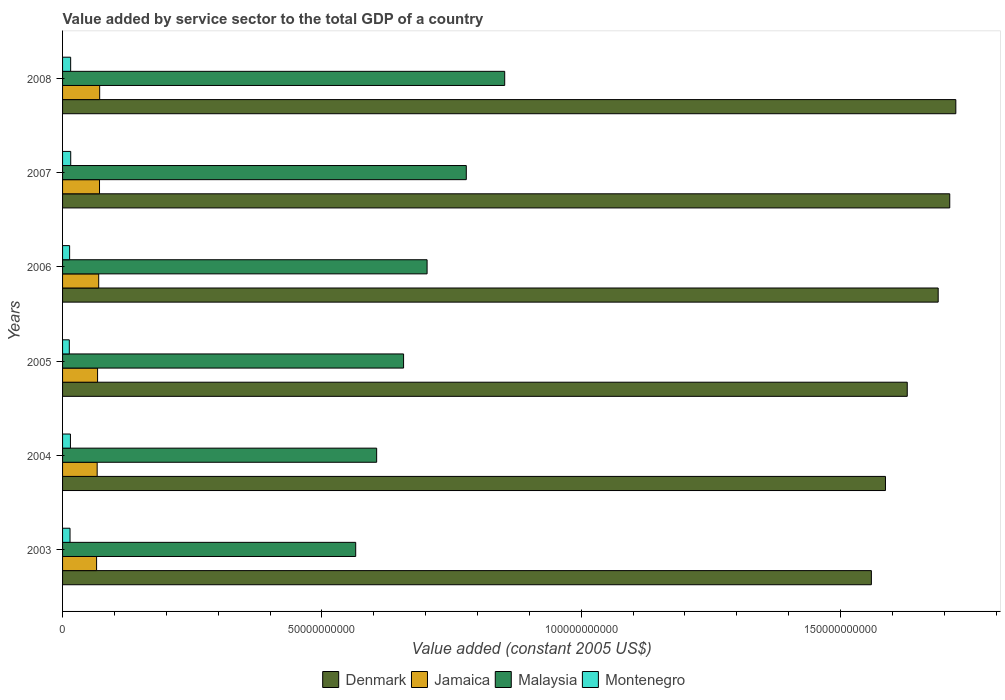How many groups of bars are there?
Your answer should be very brief. 6. Are the number of bars per tick equal to the number of legend labels?
Provide a short and direct response. Yes. How many bars are there on the 4th tick from the bottom?
Make the answer very short. 4. What is the label of the 1st group of bars from the top?
Make the answer very short. 2008. In how many cases, is the number of bars for a given year not equal to the number of legend labels?
Give a very brief answer. 0. What is the value added by service sector in Malaysia in 2008?
Give a very brief answer. 8.53e+1. Across all years, what is the maximum value added by service sector in Montenegro?
Offer a very short reply. 1.57e+09. Across all years, what is the minimum value added by service sector in Malaysia?
Provide a succinct answer. 5.65e+1. In which year was the value added by service sector in Malaysia minimum?
Offer a terse response. 2003. What is the total value added by service sector in Malaysia in the graph?
Your answer should be very brief. 4.16e+11. What is the difference between the value added by service sector in Jamaica in 2003 and that in 2007?
Offer a very short reply. -5.63e+08. What is the difference between the value added by service sector in Malaysia in 2006 and the value added by service sector in Denmark in 2007?
Offer a very short reply. -1.01e+11. What is the average value added by service sector in Malaysia per year?
Keep it short and to the point. 6.94e+1. In the year 2008, what is the difference between the value added by service sector in Jamaica and value added by service sector in Malaysia?
Ensure brevity in your answer.  -7.81e+1. What is the ratio of the value added by service sector in Denmark in 2004 to that in 2005?
Offer a very short reply. 0.97. Is the value added by service sector in Jamaica in 2006 less than that in 2008?
Provide a short and direct response. Yes. Is the difference between the value added by service sector in Jamaica in 2006 and 2007 greater than the difference between the value added by service sector in Malaysia in 2006 and 2007?
Offer a terse response. Yes. What is the difference between the highest and the second highest value added by service sector in Jamaica?
Your answer should be very brief. 2.92e+07. What is the difference between the highest and the lowest value added by service sector in Denmark?
Offer a very short reply. 1.63e+1. Is it the case that in every year, the sum of the value added by service sector in Montenegro and value added by service sector in Jamaica is greater than the sum of value added by service sector in Denmark and value added by service sector in Malaysia?
Your answer should be compact. No. What does the 3rd bar from the top in 2004 represents?
Provide a succinct answer. Jamaica. What does the 3rd bar from the bottom in 2008 represents?
Your answer should be compact. Malaysia. Is it the case that in every year, the sum of the value added by service sector in Montenegro and value added by service sector in Denmark is greater than the value added by service sector in Jamaica?
Provide a short and direct response. Yes. How many bars are there?
Provide a succinct answer. 24. Are all the bars in the graph horizontal?
Your answer should be compact. Yes. How many years are there in the graph?
Give a very brief answer. 6. Are the values on the major ticks of X-axis written in scientific E-notation?
Give a very brief answer. No. Where does the legend appear in the graph?
Ensure brevity in your answer.  Bottom center. How many legend labels are there?
Your answer should be compact. 4. What is the title of the graph?
Your response must be concise. Value added by service sector to the total GDP of a country. Does "Middle East & North Africa (developing only)" appear as one of the legend labels in the graph?
Offer a terse response. No. What is the label or title of the X-axis?
Give a very brief answer. Value added (constant 2005 US$). What is the label or title of the Y-axis?
Your answer should be compact. Years. What is the Value added (constant 2005 US$) of Denmark in 2003?
Offer a terse response. 1.56e+11. What is the Value added (constant 2005 US$) in Jamaica in 2003?
Offer a very short reply. 6.56e+09. What is the Value added (constant 2005 US$) of Malaysia in 2003?
Provide a short and direct response. 5.65e+1. What is the Value added (constant 2005 US$) of Montenegro in 2003?
Ensure brevity in your answer.  1.44e+09. What is the Value added (constant 2005 US$) in Denmark in 2004?
Make the answer very short. 1.59e+11. What is the Value added (constant 2005 US$) in Jamaica in 2004?
Your answer should be very brief. 6.67e+09. What is the Value added (constant 2005 US$) in Malaysia in 2004?
Your answer should be compact. 6.06e+1. What is the Value added (constant 2005 US$) in Montenegro in 2004?
Give a very brief answer. 1.52e+09. What is the Value added (constant 2005 US$) of Denmark in 2005?
Give a very brief answer. 1.63e+11. What is the Value added (constant 2005 US$) in Jamaica in 2005?
Your answer should be compact. 6.75e+09. What is the Value added (constant 2005 US$) of Malaysia in 2005?
Give a very brief answer. 6.58e+1. What is the Value added (constant 2005 US$) in Montenegro in 2005?
Your answer should be very brief. 1.30e+09. What is the Value added (constant 2005 US$) in Denmark in 2006?
Your answer should be compact. 1.69e+11. What is the Value added (constant 2005 US$) of Jamaica in 2006?
Provide a succinct answer. 6.97e+09. What is the Value added (constant 2005 US$) in Malaysia in 2006?
Offer a terse response. 7.03e+1. What is the Value added (constant 2005 US$) in Montenegro in 2006?
Provide a succinct answer. 1.36e+09. What is the Value added (constant 2005 US$) in Denmark in 2007?
Make the answer very short. 1.71e+11. What is the Value added (constant 2005 US$) of Jamaica in 2007?
Make the answer very short. 7.12e+09. What is the Value added (constant 2005 US$) of Malaysia in 2007?
Provide a short and direct response. 7.78e+1. What is the Value added (constant 2005 US$) in Montenegro in 2007?
Give a very brief answer. 1.57e+09. What is the Value added (constant 2005 US$) in Denmark in 2008?
Make the answer very short. 1.72e+11. What is the Value added (constant 2005 US$) of Jamaica in 2008?
Make the answer very short. 7.15e+09. What is the Value added (constant 2005 US$) of Malaysia in 2008?
Keep it short and to the point. 8.53e+1. What is the Value added (constant 2005 US$) of Montenegro in 2008?
Keep it short and to the point. 1.56e+09. Across all years, what is the maximum Value added (constant 2005 US$) of Denmark?
Make the answer very short. 1.72e+11. Across all years, what is the maximum Value added (constant 2005 US$) of Jamaica?
Offer a terse response. 7.15e+09. Across all years, what is the maximum Value added (constant 2005 US$) in Malaysia?
Keep it short and to the point. 8.53e+1. Across all years, what is the maximum Value added (constant 2005 US$) of Montenegro?
Offer a very short reply. 1.57e+09. Across all years, what is the minimum Value added (constant 2005 US$) in Denmark?
Ensure brevity in your answer.  1.56e+11. Across all years, what is the minimum Value added (constant 2005 US$) of Jamaica?
Give a very brief answer. 6.56e+09. Across all years, what is the minimum Value added (constant 2005 US$) in Malaysia?
Offer a very short reply. 5.65e+1. Across all years, what is the minimum Value added (constant 2005 US$) of Montenegro?
Your response must be concise. 1.30e+09. What is the total Value added (constant 2005 US$) of Denmark in the graph?
Ensure brevity in your answer.  9.90e+11. What is the total Value added (constant 2005 US$) in Jamaica in the graph?
Provide a short and direct response. 4.12e+1. What is the total Value added (constant 2005 US$) of Malaysia in the graph?
Offer a very short reply. 4.16e+11. What is the total Value added (constant 2005 US$) in Montenegro in the graph?
Offer a very short reply. 8.75e+09. What is the difference between the Value added (constant 2005 US$) of Denmark in 2003 and that in 2004?
Offer a very short reply. -2.72e+09. What is the difference between the Value added (constant 2005 US$) in Jamaica in 2003 and that in 2004?
Ensure brevity in your answer.  -1.10e+08. What is the difference between the Value added (constant 2005 US$) of Malaysia in 2003 and that in 2004?
Make the answer very short. -4.04e+09. What is the difference between the Value added (constant 2005 US$) of Montenegro in 2003 and that in 2004?
Offer a very short reply. -7.69e+07. What is the difference between the Value added (constant 2005 US$) of Denmark in 2003 and that in 2005?
Give a very brief answer. -6.92e+09. What is the difference between the Value added (constant 2005 US$) in Jamaica in 2003 and that in 2005?
Offer a very short reply. -1.91e+08. What is the difference between the Value added (constant 2005 US$) of Malaysia in 2003 and that in 2005?
Your answer should be very brief. -9.23e+09. What is the difference between the Value added (constant 2005 US$) of Montenegro in 2003 and that in 2005?
Offer a terse response. 1.39e+08. What is the difference between the Value added (constant 2005 US$) in Denmark in 2003 and that in 2006?
Offer a terse response. -1.29e+1. What is the difference between the Value added (constant 2005 US$) in Jamaica in 2003 and that in 2006?
Make the answer very short. -4.08e+08. What is the difference between the Value added (constant 2005 US$) of Malaysia in 2003 and that in 2006?
Provide a succinct answer. -1.38e+1. What is the difference between the Value added (constant 2005 US$) of Montenegro in 2003 and that in 2006?
Provide a succinct answer. 7.83e+07. What is the difference between the Value added (constant 2005 US$) in Denmark in 2003 and that in 2007?
Offer a terse response. -1.51e+1. What is the difference between the Value added (constant 2005 US$) of Jamaica in 2003 and that in 2007?
Your response must be concise. -5.63e+08. What is the difference between the Value added (constant 2005 US$) of Malaysia in 2003 and that in 2007?
Keep it short and to the point. -2.13e+1. What is the difference between the Value added (constant 2005 US$) of Montenegro in 2003 and that in 2007?
Provide a short and direct response. -1.31e+08. What is the difference between the Value added (constant 2005 US$) of Denmark in 2003 and that in 2008?
Provide a succinct answer. -1.63e+1. What is the difference between the Value added (constant 2005 US$) in Jamaica in 2003 and that in 2008?
Ensure brevity in your answer.  -5.92e+08. What is the difference between the Value added (constant 2005 US$) in Malaysia in 2003 and that in 2008?
Your answer should be compact. -2.87e+1. What is the difference between the Value added (constant 2005 US$) of Montenegro in 2003 and that in 2008?
Keep it short and to the point. -1.21e+08. What is the difference between the Value added (constant 2005 US$) in Denmark in 2004 and that in 2005?
Give a very brief answer. -4.20e+09. What is the difference between the Value added (constant 2005 US$) in Jamaica in 2004 and that in 2005?
Keep it short and to the point. -8.05e+07. What is the difference between the Value added (constant 2005 US$) in Malaysia in 2004 and that in 2005?
Ensure brevity in your answer.  -5.19e+09. What is the difference between the Value added (constant 2005 US$) in Montenegro in 2004 and that in 2005?
Your response must be concise. 2.16e+08. What is the difference between the Value added (constant 2005 US$) in Denmark in 2004 and that in 2006?
Offer a terse response. -1.02e+1. What is the difference between the Value added (constant 2005 US$) of Jamaica in 2004 and that in 2006?
Your response must be concise. -2.97e+08. What is the difference between the Value added (constant 2005 US$) of Malaysia in 2004 and that in 2006?
Provide a short and direct response. -9.72e+09. What is the difference between the Value added (constant 2005 US$) in Montenegro in 2004 and that in 2006?
Provide a succinct answer. 1.55e+08. What is the difference between the Value added (constant 2005 US$) of Denmark in 2004 and that in 2007?
Provide a succinct answer. -1.24e+1. What is the difference between the Value added (constant 2005 US$) in Jamaica in 2004 and that in 2007?
Offer a terse response. -4.53e+08. What is the difference between the Value added (constant 2005 US$) in Malaysia in 2004 and that in 2007?
Keep it short and to the point. -1.73e+1. What is the difference between the Value added (constant 2005 US$) of Montenegro in 2004 and that in 2007?
Keep it short and to the point. -5.41e+07. What is the difference between the Value added (constant 2005 US$) in Denmark in 2004 and that in 2008?
Your answer should be compact. -1.36e+1. What is the difference between the Value added (constant 2005 US$) in Jamaica in 2004 and that in 2008?
Ensure brevity in your answer.  -4.82e+08. What is the difference between the Value added (constant 2005 US$) of Malaysia in 2004 and that in 2008?
Give a very brief answer. -2.47e+1. What is the difference between the Value added (constant 2005 US$) of Montenegro in 2004 and that in 2008?
Provide a succinct answer. -4.37e+07. What is the difference between the Value added (constant 2005 US$) of Denmark in 2005 and that in 2006?
Offer a terse response. -5.96e+09. What is the difference between the Value added (constant 2005 US$) of Jamaica in 2005 and that in 2006?
Your answer should be very brief. -2.17e+08. What is the difference between the Value added (constant 2005 US$) in Malaysia in 2005 and that in 2006?
Make the answer very short. -4.53e+09. What is the difference between the Value added (constant 2005 US$) in Montenegro in 2005 and that in 2006?
Ensure brevity in your answer.  -6.05e+07. What is the difference between the Value added (constant 2005 US$) of Denmark in 2005 and that in 2007?
Provide a succinct answer. -8.19e+09. What is the difference between the Value added (constant 2005 US$) in Jamaica in 2005 and that in 2007?
Offer a terse response. -3.72e+08. What is the difference between the Value added (constant 2005 US$) of Malaysia in 2005 and that in 2007?
Offer a very short reply. -1.21e+1. What is the difference between the Value added (constant 2005 US$) in Montenegro in 2005 and that in 2007?
Keep it short and to the point. -2.70e+08. What is the difference between the Value added (constant 2005 US$) in Denmark in 2005 and that in 2008?
Provide a succinct answer. -9.37e+09. What is the difference between the Value added (constant 2005 US$) of Jamaica in 2005 and that in 2008?
Keep it short and to the point. -4.02e+08. What is the difference between the Value added (constant 2005 US$) in Malaysia in 2005 and that in 2008?
Offer a very short reply. -1.95e+1. What is the difference between the Value added (constant 2005 US$) in Montenegro in 2005 and that in 2008?
Make the answer very short. -2.59e+08. What is the difference between the Value added (constant 2005 US$) in Denmark in 2006 and that in 2007?
Give a very brief answer. -2.23e+09. What is the difference between the Value added (constant 2005 US$) in Jamaica in 2006 and that in 2007?
Give a very brief answer. -1.55e+08. What is the difference between the Value added (constant 2005 US$) in Malaysia in 2006 and that in 2007?
Provide a succinct answer. -7.56e+09. What is the difference between the Value added (constant 2005 US$) of Montenegro in 2006 and that in 2007?
Offer a very short reply. -2.09e+08. What is the difference between the Value added (constant 2005 US$) in Denmark in 2006 and that in 2008?
Make the answer very short. -3.40e+09. What is the difference between the Value added (constant 2005 US$) in Jamaica in 2006 and that in 2008?
Your answer should be very brief. -1.85e+08. What is the difference between the Value added (constant 2005 US$) of Malaysia in 2006 and that in 2008?
Your answer should be compact. -1.50e+1. What is the difference between the Value added (constant 2005 US$) in Montenegro in 2006 and that in 2008?
Your response must be concise. -1.99e+08. What is the difference between the Value added (constant 2005 US$) of Denmark in 2007 and that in 2008?
Your response must be concise. -1.17e+09. What is the difference between the Value added (constant 2005 US$) in Jamaica in 2007 and that in 2008?
Offer a terse response. -2.92e+07. What is the difference between the Value added (constant 2005 US$) of Malaysia in 2007 and that in 2008?
Provide a succinct answer. -7.41e+09. What is the difference between the Value added (constant 2005 US$) in Montenegro in 2007 and that in 2008?
Ensure brevity in your answer.  1.04e+07. What is the difference between the Value added (constant 2005 US$) of Denmark in 2003 and the Value added (constant 2005 US$) of Jamaica in 2004?
Make the answer very short. 1.49e+11. What is the difference between the Value added (constant 2005 US$) of Denmark in 2003 and the Value added (constant 2005 US$) of Malaysia in 2004?
Make the answer very short. 9.54e+1. What is the difference between the Value added (constant 2005 US$) of Denmark in 2003 and the Value added (constant 2005 US$) of Montenegro in 2004?
Provide a short and direct response. 1.54e+11. What is the difference between the Value added (constant 2005 US$) of Jamaica in 2003 and the Value added (constant 2005 US$) of Malaysia in 2004?
Give a very brief answer. -5.40e+1. What is the difference between the Value added (constant 2005 US$) in Jamaica in 2003 and the Value added (constant 2005 US$) in Montenegro in 2004?
Offer a very short reply. 5.04e+09. What is the difference between the Value added (constant 2005 US$) of Malaysia in 2003 and the Value added (constant 2005 US$) of Montenegro in 2004?
Your answer should be very brief. 5.50e+1. What is the difference between the Value added (constant 2005 US$) of Denmark in 2003 and the Value added (constant 2005 US$) of Jamaica in 2005?
Ensure brevity in your answer.  1.49e+11. What is the difference between the Value added (constant 2005 US$) of Denmark in 2003 and the Value added (constant 2005 US$) of Malaysia in 2005?
Give a very brief answer. 9.02e+1. What is the difference between the Value added (constant 2005 US$) in Denmark in 2003 and the Value added (constant 2005 US$) in Montenegro in 2005?
Give a very brief answer. 1.55e+11. What is the difference between the Value added (constant 2005 US$) in Jamaica in 2003 and the Value added (constant 2005 US$) in Malaysia in 2005?
Offer a very short reply. -5.92e+1. What is the difference between the Value added (constant 2005 US$) of Jamaica in 2003 and the Value added (constant 2005 US$) of Montenegro in 2005?
Offer a terse response. 5.26e+09. What is the difference between the Value added (constant 2005 US$) of Malaysia in 2003 and the Value added (constant 2005 US$) of Montenegro in 2005?
Keep it short and to the point. 5.52e+1. What is the difference between the Value added (constant 2005 US$) of Denmark in 2003 and the Value added (constant 2005 US$) of Jamaica in 2006?
Your answer should be compact. 1.49e+11. What is the difference between the Value added (constant 2005 US$) of Denmark in 2003 and the Value added (constant 2005 US$) of Malaysia in 2006?
Offer a very short reply. 8.57e+1. What is the difference between the Value added (constant 2005 US$) of Denmark in 2003 and the Value added (constant 2005 US$) of Montenegro in 2006?
Offer a terse response. 1.55e+11. What is the difference between the Value added (constant 2005 US$) in Jamaica in 2003 and the Value added (constant 2005 US$) in Malaysia in 2006?
Your answer should be very brief. -6.37e+1. What is the difference between the Value added (constant 2005 US$) of Jamaica in 2003 and the Value added (constant 2005 US$) of Montenegro in 2006?
Ensure brevity in your answer.  5.20e+09. What is the difference between the Value added (constant 2005 US$) in Malaysia in 2003 and the Value added (constant 2005 US$) in Montenegro in 2006?
Your response must be concise. 5.52e+1. What is the difference between the Value added (constant 2005 US$) of Denmark in 2003 and the Value added (constant 2005 US$) of Jamaica in 2007?
Make the answer very short. 1.49e+11. What is the difference between the Value added (constant 2005 US$) in Denmark in 2003 and the Value added (constant 2005 US$) in Malaysia in 2007?
Your answer should be compact. 7.81e+1. What is the difference between the Value added (constant 2005 US$) of Denmark in 2003 and the Value added (constant 2005 US$) of Montenegro in 2007?
Make the answer very short. 1.54e+11. What is the difference between the Value added (constant 2005 US$) in Jamaica in 2003 and the Value added (constant 2005 US$) in Malaysia in 2007?
Make the answer very short. -7.13e+1. What is the difference between the Value added (constant 2005 US$) of Jamaica in 2003 and the Value added (constant 2005 US$) of Montenegro in 2007?
Your answer should be very brief. 4.99e+09. What is the difference between the Value added (constant 2005 US$) of Malaysia in 2003 and the Value added (constant 2005 US$) of Montenegro in 2007?
Ensure brevity in your answer.  5.50e+1. What is the difference between the Value added (constant 2005 US$) of Denmark in 2003 and the Value added (constant 2005 US$) of Jamaica in 2008?
Provide a succinct answer. 1.49e+11. What is the difference between the Value added (constant 2005 US$) of Denmark in 2003 and the Value added (constant 2005 US$) of Malaysia in 2008?
Offer a terse response. 7.07e+1. What is the difference between the Value added (constant 2005 US$) in Denmark in 2003 and the Value added (constant 2005 US$) in Montenegro in 2008?
Offer a terse response. 1.54e+11. What is the difference between the Value added (constant 2005 US$) in Jamaica in 2003 and the Value added (constant 2005 US$) in Malaysia in 2008?
Provide a succinct answer. -7.87e+1. What is the difference between the Value added (constant 2005 US$) of Jamaica in 2003 and the Value added (constant 2005 US$) of Montenegro in 2008?
Give a very brief answer. 5.00e+09. What is the difference between the Value added (constant 2005 US$) of Malaysia in 2003 and the Value added (constant 2005 US$) of Montenegro in 2008?
Offer a very short reply. 5.50e+1. What is the difference between the Value added (constant 2005 US$) of Denmark in 2004 and the Value added (constant 2005 US$) of Jamaica in 2005?
Make the answer very short. 1.52e+11. What is the difference between the Value added (constant 2005 US$) in Denmark in 2004 and the Value added (constant 2005 US$) in Malaysia in 2005?
Ensure brevity in your answer.  9.29e+1. What is the difference between the Value added (constant 2005 US$) in Denmark in 2004 and the Value added (constant 2005 US$) in Montenegro in 2005?
Provide a succinct answer. 1.57e+11. What is the difference between the Value added (constant 2005 US$) of Jamaica in 2004 and the Value added (constant 2005 US$) of Malaysia in 2005?
Your answer should be very brief. -5.91e+1. What is the difference between the Value added (constant 2005 US$) in Jamaica in 2004 and the Value added (constant 2005 US$) in Montenegro in 2005?
Your answer should be very brief. 5.37e+09. What is the difference between the Value added (constant 2005 US$) in Malaysia in 2004 and the Value added (constant 2005 US$) in Montenegro in 2005?
Your answer should be very brief. 5.93e+1. What is the difference between the Value added (constant 2005 US$) of Denmark in 2004 and the Value added (constant 2005 US$) of Jamaica in 2006?
Provide a succinct answer. 1.52e+11. What is the difference between the Value added (constant 2005 US$) in Denmark in 2004 and the Value added (constant 2005 US$) in Malaysia in 2006?
Your answer should be very brief. 8.84e+1. What is the difference between the Value added (constant 2005 US$) of Denmark in 2004 and the Value added (constant 2005 US$) of Montenegro in 2006?
Provide a succinct answer. 1.57e+11. What is the difference between the Value added (constant 2005 US$) in Jamaica in 2004 and the Value added (constant 2005 US$) in Malaysia in 2006?
Provide a succinct answer. -6.36e+1. What is the difference between the Value added (constant 2005 US$) in Jamaica in 2004 and the Value added (constant 2005 US$) in Montenegro in 2006?
Your response must be concise. 5.31e+09. What is the difference between the Value added (constant 2005 US$) of Malaysia in 2004 and the Value added (constant 2005 US$) of Montenegro in 2006?
Make the answer very short. 5.92e+1. What is the difference between the Value added (constant 2005 US$) of Denmark in 2004 and the Value added (constant 2005 US$) of Jamaica in 2007?
Keep it short and to the point. 1.52e+11. What is the difference between the Value added (constant 2005 US$) in Denmark in 2004 and the Value added (constant 2005 US$) in Malaysia in 2007?
Keep it short and to the point. 8.08e+1. What is the difference between the Value added (constant 2005 US$) of Denmark in 2004 and the Value added (constant 2005 US$) of Montenegro in 2007?
Offer a terse response. 1.57e+11. What is the difference between the Value added (constant 2005 US$) of Jamaica in 2004 and the Value added (constant 2005 US$) of Malaysia in 2007?
Your answer should be compact. -7.12e+1. What is the difference between the Value added (constant 2005 US$) of Jamaica in 2004 and the Value added (constant 2005 US$) of Montenegro in 2007?
Your response must be concise. 5.10e+09. What is the difference between the Value added (constant 2005 US$) of Malaysia in 2004 and the Value added (constant 2005 US$) of Montenegro in 2007?
Offer a terse response. 5.90e+1. What is the difference between the Value added (constant 2005 US$) of Denmark in 2004 and the Value added (constant 2005 US$) of Jamaica in 2008?
Offer a very short reply. 1.52e+11. What is the difference between the Value added (constant 2005 US$) in Denmark in 2004 and the Value added (constant 2005 US$) in Malaysia in 2008?
Provide a short and direct response. 7.34e+1. What is the difference between the Value added (constant 2005 US$) of Denmark in 2004 and the Value added (constant 2005 US$) of Montenegro in 2008?
Make the answer very short. 1.57e+11. What is the difference between the Value added (constant 2005 US$) in Jamaica in 2004 and the Value added (constant 2005 US$) in Malaysia in 2008?
Provide a succinct answer. -7.86e+1. What is the difference between the Value added (constant 2005 US$) in Jamaica in 2004 and the Value added (constant 2005 US$) in Montenegro in 2008?
Your answer should be compact. 5.11e+09. What is the difference between the Value added (constant 2005 US$) in Malaysia in 2004 and the Value added (constant 2005 US$) in Montenegro in 2008?
Offer a very short reply. 5.90e+1. What is the difference between the Value added (constant 2005 US$) in Denmark in 2005 and the Value added (constant 2005 US$) in Jamaica in 2006?
Ensure brevity in your answer.  1.56e+11. What is the difference between the Value added (constant 2005 US$) in Denmark in 2005 and the Value added (constant 2005 US$) in Malaysia in 2006?
Provide a succinct answer. 9.26e+1. What is the difference between the Value added (constant 2005 US$) in Denmark in 2005 and the Value added (constant 2005 US$) in Montenegro in 2006?
Keep it short and to the point. 1.62e+11. What is the difference between the Value added (constant 2005 US$) of Jamaica in 2005 and the Value added (constant 2005 US$) of Malaysia in 2006?
Ensure brevity in your answer.  -6.35e+1. What is the difference between the Value added (constant 2005 US$) in Jamaica in 2005 and the Value added (constant 2005 US$) in Montenegro in 2006?
Keep it short and to the point. 5.39e+09. What is the difference between the Value added (constant 2005 US$) of Malaysia in 2005 and the Value added (constant 2005 US$) of Montenegro in 2006?
Offer a very short reply. 6.44e+1. What is the difference between the Value added (constant 2005 US$) of Denmark in 2005 and the Value added (constant 2005 US$) of Jamaica in 2007?
Give a very brief answer. 1.56e+11. What is the difference between the Value added (constant 2005 US$) in Denmark in 2005 and the Value added (constant 2005 US$) in Malaysia in 2007?
Your answer should be compact. 8.50e+1. What is the difference between the Value added (constant 2005 US$) of Denmark in 2005 and the Value added (constant 2005 US$) of Montenegro in 2007?
Your response must be concise. 1.61e+11. What is the difference between the Value added (constant 2005 US$) in Jamaica in 2005 and the Value added (constant 2005 US$) in Malaysia in 2007?
Your response must be concise. -7.11e+1. What is the difference between the Value added (constant 2005 US$) of Jamaica in 2005 and the Value added (constant 2005 US$) of Montenegro in 2007?
Your answer should be very brief. 5.18e+09. What is the difference between the Value added (constant 2005 US$) of Malaysia in 2005 and the Value added (constant 2005 US$) of Montenegro in 2007?
Give a very brief answer. 6.42e+1. What is the difference between the Value added (constant 2005 US$) of Denmark in 2005 and the Value added (constant 2005 US$) of Jamaica in 2008?
Your answer should be compact. 1.56e+11. What is the difference between the Value added (constant 2005 US$) in Denmark in 2005 and the Value added (constant 2005 US$) in Malaysia in 2008?
Give a very brief answer. 7.76e+1. What is the difference between the Value added (constant 2005 US$) of Denmark in 2005 and the Value added (constant 2005 US$) of Montenegro in 2008?
Offer a very short reply. 1.61e+11. What is the difference between the Value added (constant 2005 US$) in Jamaica in 2005 and the Value added (constant 2005 US$) in Malaysia in 2008?
Offer a terse response. -7.85e+1. What is the difference between the Value added (constant 2005 US$) in Jamaica in 2005 and the Value added (constant 2005 US$) in Montenegro in 2008?
Your answer should be very brief. 5.19e+09. What is the difference between the Value added (constant 2005 US$) of Malaysia in 2005 and the Value added (constant 2005 US$) of Montenegro in 2008?
Your response must be concise. 6.42e+1. What is the difference between the Value added (constant 2005 US$) of Denmark in 2006 and the Value added (constant 2005 US$) of Jamaica in 2007?
Offer a terse response. 1.62e+11. What is the difference between the Value added (constant 2005 US$) in Denmark in 2006 and the Value added (constant 2005 US$) in Malaysia in 2007?
Offer a terse response. 9.10e+1. What is the difference between the Value added (constant 2005 US$) in Denmark in 2006 and the Value added (constant 2005 US$) in Montenegro in 2007?
Offer a very short reply. 1.67e+11. What is the difference between the Value added (constant 2005 US$) of Jamaica in 2006 and the Value added (constant 2005 US$) of Malaysia in 2007?
Provide a short and direct response. -7.09e+1. What is the difference between the Value added (constant 2005 US$) in Jamaica in 2006 and the Value added (constant 2005 US$) in Montenegro in 2007?
Provide a short and direct response. 5.40e+09. What is the difference between the Value added (constant 2005 US$) in Malaysia in 2006 and the Value added (constant 2005 US$) in Montenegro in 2007?
Provide a succinct answer. 6.87e+1. What is the difference between the Value added (constant 2005 US$) in Denmark in 2006 and the Value added (constant 2005 US$) in Jamaica in 2008?
Keep it short and to the point. 1.62e+11. What is the difference between the Value added (constant 2005 US$) of Denmark in 2006 and the Value added (constant 2005 US$) of Malaysia in 2008?
Your answer should be compact. 8.36e+1. What is the difference between the Value added (constant 2005 US$) of Denmark in 2006 and the Value added (constant 2005 US$) of Montenegro in 2008?
Provide a short and direct response. 1.67e+11. What is the difference between the Value added (constant 2005 US$) of Jamaica in 2006 and the Value added (constant 2005 US$) of Malaysia in 2008?
Provide a succinct answer. -7.83e+1. What is the difference between the Value added (constant 2005 US$) in Jamaica in 2006 and the Value added (constant 2005 US$) in Montenegro in 2008?
Make the answer very short. 5.41e+09. What is the difference between the Value added (constant 2005 US$) of Malaysia in 2006 and the Value added (constant 2005 US$) of Montenegro in 2008?
Offer a very short reply. 6.87e+1. What is the difference between the Value added (constant 2005 US$) in Denmark in 2007 and the Value added (constant 2005 US$) in Jamaica in 2008?
Ensure brevity in your answer.  1.64e+11. What is the difference between the Value added (constant 2005 US$) in Denmark in 2007 and the Value added (constant 2005 US$) in Malaysia in 2008?
Ensure brevity in your answer.  8.58e+1. What is the difference between the Value added (constant 2005 US$) of Denmark in 2007 and the Value added (constant 2005 US$) of Montenegro in 2008?
Make the answer very short. 1.70e+11. What is the difference between the Value added (constant 2005 US$) of Jamaica in 2007 and the Value added (constant 2005 US$) of Malaysia in 2008?
Your answer should be compact. -7.81e+1. What is the difference between the Value added (constant 2005 US$) of Jamaica in 2007 and the Value added (constant 2005 US$) of Montenegro in 2008?
Ensure brevity in your answer.  5.56e+09. What is the difference between the Value added (constant 2005 US$) of Malaysia in 2007 and the Value added (constant 2005 US$) of Montenegro in 2008?
Give a very brief answer. 7.63e+1. What is the average Value added (constant 2005 US$) in Denmark per year?
Make the answer very short. 1.65e+11. What is the average Value added (constant 2005 US$) of Jamaica per year?
Offer a very short reply. 6.87e+09. What is the average Value added (constant 2005 US$) of Malaysia per year?
Give a very brief answer. 6.94e+1. What is the average Value added (constant 2005 US$) of Montenegro per year?
Your answer should be very brief. 1.46e+09. In the year 2003, what is the difference between the Value added (constant 2005 US$) of Denmark and Value added (constant 2005 US$) of Jamaica?
Provide a short and direct response. 1.49e+11. In the year 2003, what is the difference between the Value added (constant 2005 US$) of Denmark and Value added (constant 2005 US$) of Malaysia?
Ensure brevity in your answer.  9.94e+1. In the year 2003, what is the difference between the Value added (constant 2005 US$) in Denmark and Value added (constant 2005 US$) in Montenegro?
Offer a very short reply. 1.55e+11. In the year 2003, what is the difference between the Value added (constant 2005 US$) of Jamaica and Value added (constant 2005 US$) of Malaysia?
Offer a very short reply. -5.00e+1. In the year 2003, what is the difference between the Value added (constant 2005 US$) in Jamaica and Value added (constant 2005 US$) in Montenegro?
Your answer should be very brief. 5.12e+09. In the year 2003, what is the difference between the Value added (constant 2005 US$) of Malaysia and Value added (constant 2005 US$) of Montenegro?
Offer a terse response. 5.51e+1. In the year 2004, what is the difference between the Value added (constant 2005 US$) in Denmark and Value added (constant 2005 US$) in Jamaica?
Keep it short and to the point. 1.52e+11. In the year 2004, what is the difference between the Value added (constant 2005 US$) in Denmark and Value added (constant 2005 US$) in Malaysia?
Offer a terse response. 9.81e+1. In the year 2004, what is the difference between the Value added (constant 2005 US$) of Denmark and Value added (constant 2005 US$) of Montenegro?
Your answer should be very brief. 1.57e+11. In the year 2004, what is the difference between the Value added (constant 2005 US$) in Jamaica and Value added (constant 2005 US$) in Malaysia?
Give a very brief answer. -5.39e+1. In the year 2004, what is the difference between the Value added (constant 2005 US$) of Jamaica and Value added (constant 2005 US$) of Montenegro?
Keep it short and to the point. 5.15e+09. In the year 2004, what is the difference between the Value added (constant 2005 US$) of Malaysia and Value added (constant 2005 US$) of Montenegro?
Offer a very short reply. 5.90e+1. In the year 2005, what is the difference between the Value added (constant 2005 US$) of Denmark and Value added (constant 2005 US$) of Jamaica?
Offer a terse response. 1.56e+11. In the year 2005, what is the difference between the Value added (constant 2005 US$) in Denmark and Value added (constant 2005 US$) in Malaysia?
Keep it short and to the point. 9.71e+1. In the year 2005, what is the difference between the Value added (constant 2005 US$) in Denmark and Value added (constant 2005 US$) in Montenegro?
Your response must be concise. 1.62e+11. In the year 2005, what is the difference between the Value added (constant 2005 US$) in Jamaica and Value added (constant 2005 US$) in Malaysia?
Offer a very short reply. -5.90e+1. In the year 2005, what is the difference between the Value added (constant 2005 US$) of Jamaica and Value added (constant 2005 US$) of Montenegro?
Give a very brief answer. 5.45e+09. In the year 2005, what is the difference between the Value added (constant 2005 US$) in Malaysia and Value added (constant 2005 US$) in Montenegro?
Your response must be concise. 6.45e+1. In the year 2006, what is the difference between the Value added (constant 2005 US$) of Denmark and Value added (constant 2005 US$) of Jamaica?
Provide a succinct answer. 1.62e+11. In the year 2006, what is the difference between the Value added (constant 2005 US$) of Denmark and Value added (constant 2005 US$) of Malaysia?
Offer a very short reply. 9.85e+1. In the year 2006, what is the difference between the Value added (constant 2005 US$) in Denmark and Value added (constant 2005 US$) in Montenegro?
Make the answer very short. 1.67e+11. In the year 2006, what is the difference between the Value added (constant 2005 US$) of Jamaica and Value added (constant 2005 US$) of Malaysia?
Your response must be concise. -6.33e+1. In the year 2006, what is the difference between the Value added (constant 2005 US$) in Jamaica and Value added (constant 2005 US$) in Montenegro?
Offer a very short reply. 5.61e+09. In the year 2006, what is the difference between the Value added (constant 2005 US$) in Malaysia and Value added (constant 2005 US$) in Montenegro?
Provide a short and direct response. 6.89e+1. In the year 2007, what is the difference between the Value added (constant 2005 US$) of Denmark and Value added (constant 2005 US$) of Jamaica?
Your answer should be compact. 1.64e+11. In the year 2007, what is the difference between the Value added (constant 2005 US$) of Denmark and Value added (constant 2005 US$) of Malaysia?
Provide a short and direct response. 9.32e+1. In the year 2007, what is the difference between the Value added (constant 2005 US$) in Denmark and Value added (constant 2005 US$) in Montenegro?
Your response must be concise. 1.69e+11. In the year 2007, what is the difference between the Value added (constant 2005 US$) of Jamaica and Value added (constant 2005 US$) of Malaysia?
Ensure brevity in your answer.  -7.07e+1. In the year 2007, what is the difference between the Value added (constant 2005 US$) in Jamaica and Value added (constant 2005 US$) in Montenegro?
Ensure brevity in your answer.  5.55e+09. In the year 2007, what is the difference between the Value added (constant 2005 US$) in Malaysia and Value added (constant 2005 US$) in Montenegro?
Your response must be concise. 7.63e+1. In the year 2008, what is the difference between the Value added (constant 2005 US$) in Denmark and Value added (constant 2005 US$) in Jamaica?
Provide a succinct answer. 1.65e+11. In the year 2008, what is the difference between the Value added (constant 2005 US$) of Denmark and Value added (constant 2005 US$) of Malaysia?
Offer a terse response. 8.70e+1. In the year 2008, what is the difference between the Value added (constant 2005 US$) of Denmark and Value added (constant 2005 US$) of Montenegro?
Provide a succinct answer. 1.71e+11. In the year 2008, what is the difference between the Value added (constant 2005 US$) in Jamaica and Value added (constant 2005 US$) in Malaysia?
Provide a succinct answer. -7.81e+1. In the year 2008, what is the difference between the Value added (constant 2005 US$) of Jamaica and Value added (constant 2005 US$) of Montenegro?
Provide a short and direct response. 5.59e+09. In the year 2008, what is the difference between the Value added (constant 2005 US$) of Malaysia and Value added (constant 2005 US$) of Montenegro?
Your answer should be very brief. 8.37e+1. What is the ratio of the Value added (constant 2005 US$) in Denmark in 2003 to that in 2004?
Give a very brief answer. 0.98. What is the ratio of the Value added (constant 2005 US$) in Jamaica in 2003 to that in 2004?
Your answer should be very brief. 0.98. What is the ratio of the Value added (constant 2005 US$) in Montenegro in 2003 to that in 2004?
Make the answer very short. 0.95. What is the ratio of the Value added (constant 2005 US$) in Denmark in 2003 to that in 2005?
Provide a succinct answer. 0.96. What is the ratio of the Value added (constant 2005 US$) in Jamaica in 2003 to that in 2005?
Ensure brevity in your answer.  0.97. What is the ratio of the Value added (constant 2005 US$) of Malaysia in 2003 to that in 2005?
Your answer should be very brief. 0.86. What is the ratio of the Value added (constant 2005 US$) of Montenegro in 2003 to that in 2005?
Provide a succinct answer. 1.11. What is the ratio of the Value added (constant 2005 US$) in Denmark in 2003 to that in 2006?
Provide a succinct answer. 0.92. What is the ratio of the Value added (constant 2005 US$) in Jamaica in 2003 to that in 2006?
Your response must be concise. 0.94. What is the ratio of the Value added (constant 2005 US$) in Malaysia in 2003 to that in 2006?
Make the answer very short. 0.8. What is the ratio of the Value added (constant 2005 US$) in Montenegro in 2003 to that in 2006?
Provide a succinct answer. 1.06. What is the ratio of the Value added (constant 2005 US$) in Denmark in 2003 to that in 2007?
Your answer should be compact. 0.91. What is the ratio of the Value added (constant 2005 US$) of Jamaica in 2003 to that in 2007?
Give a very brief answer. 0.92. What is the ratio of the Value added (constant 2005 US$) in Malaysia in 2003 to that in 2007?
Provide a short and direct response. 0.73. What is the ratio of the Value added (constant 2005 US$) of Montenegro in 2003 to that in 2007?
Your answer should be compact. 0.92. What is the ratio of the Value added (constant 2005 US$) of Denmark in 2003 to that in 2008?
Provide a short and direct response. 0.91. What is the ratio of the Value added (constant 2005 US$) of Jamaica in 2003 to that in 2008?
Provide a succinct answer. 0.92. What is the ratio of the Value added (constant 2005 US$) of Malaysia in 2003 to that in 2008?
Give a very brief answer. 0.66. What is the ratio of the Value added (constant 2005 US$) of Montenegro in 2003 to that in 2008?
Make the answer very short. 0.92. What is the ratio of the Value added (constant 2005 US$) in Denmark in 2004 to that in 2005?
Provide a short and direct response. 0.97. What is the ratio of the Value added (constant 2005 US$) in Jamaica in 2004 to that in 2005?
Your answer should be compact. 0.99. What is the ratio of the Value added (constant 2005 US$) in Malaysia in 2004 to that in 2005?
Make the answer very short. 0.92. What is the ratio of the Value added (constant 2005 US$) of Montenegro in 2004 to that in 2005?
Ensure brevity in your answer.  1.17. What is the ratio of the Value added (constant 2005 US$) of Denmark in 2004 to that in 2006?
Your response must be concise. 0.94. What is the ratio of the Value added (constant 2005 US$) in Jamaica in 2004 to that in 2006?
Ensure brevity in your answer.  0.96. What is the ratio of the Value added (constant 2005 US$) in Malaysia in 2004 to that in 2006?
Ensure brevity in your answer.  0.86. What is the ratio of the Value added (constant 2005 US$) of Montenegro in 2004 to that in 2006?
Your answer should be compact. 1.11. What is the ratio of the Value added (constant 2005 US$) in Denmark in 2004 to that in 2007?
Offer a terse response. 0.93. What is the ratio of the Value added (constant 2005 US$) in Jamaica in 2004 to that in 2007?
Provide a short and direct response. 0.94. What is the ratio of the Value added (constant 2005 US$) of Malaysia in 2004 to that in 2007?
Your answer should be very brief. 0.78. What is the ratio of the Value added (constant 2005 US$) of Montenegro in 2004 to that in 2007?
Offer a terse response. 0.97. What is the ratio of the Value added (constant 2005 US$) of Denmark in 2004 to that in 2008?
Your answer should be compact. 0.92. What is the ratio of the Value added (constant 2005 US$) in Jamaica in 2004 to that in 2008?
Provide a short and direct response. 0.93. What is the ratio of the Value added (constant 2005 US$) in Malaysia in 2004 to that in 2008?
Keep it short and to the point. 0.71. What is the ratio of the Value added (constant 2005 US$) in Denmark in 2005 to that in 2006?
Ensure brevity in your answer.  0.96. What is the ratio of the Value added (constant 2005 US$) of Jamaica in 2005 to that in 2006?
Your answer should be very brief. 0.97. What is the ratio of the Value added (constant 2005 US$) of Malaysia in 2005 to that in 2006?
Keep it short and to the point. 0.94. What is the ratio of the Value added (constant 2005 US$) of Montenegro in 2005 to that in 2006?
Keep it short and to the point. 0.96. What is the ratio of the Value added (constant 2005 US$) in Denmark in 2005 to that in 2007?
Your answer should be very brief. 0.95. What is the ratio of the Value added (constant 2005 US$) in Jamaica in 2005 to that in 2007?
Provide a short and direct response. 0.95. What is the ratio of the Value added (constant 2005 US$) in Malaysia in 2005 to that in 2007?
Offer a very short reply. 0.84. What is the ratio of the Value added (constant 2005 US$) in Montenegro in 2005 to that in 2007?
Provide a succinct answer. 0.83. What is the ratio of the Value added (constant 2005 US$) of Denmark in 2005 to that in 2008?
Make the answer very short. 0.95. What is the ratio of the Value added (constant 2005 US$) of Jamaica in 2005 to that in 2008?
Your response must be concise. 0.94. What is the ratio of the Value added (constant 2005 US$) in Malaysia in 2005 to that in 2008?
Your answer should be compact. 0.77. What is the ratio of the Value added (constant 2005 US$) in Montenegro in 2005 to that in 2008?
Ensure brevity in your answer.  0.83. What is the ratio of the Value added (constant 2005 US$) of Denmark in 2006 to that in 2007?
Offer a very short reply. 0.99. What is the ratio of the Value added (constant 2005 US$) in Jamaica in 2006 to that in 2007?
Keep it short and to the point. 0.98. What is the ratio of the Value added (constant 2005 US$) in Malaysia in 2006 to that in 2007?
Provide a succinct answer. 0.9. What is the ratio of the Value added (constant 2005 US$) in Montenegro in 2006 to that in 2007?
Make the answer very short. 0.87. What is the ratio of the Value added (constant 2005 US$) of Denmark in 2006 to that in 2008?
Your answer should be compact. 0.98. What is the ratio of the Value added (constant 2005 US$) in Jamaica in 2006 to that in 2008?
Offer a terse response. 0.97. What is the ratio of the Value added (constant 2005 US$) of Malaysia in 2006 to that in 2008?
Your answer should be very brief. 0.82. What is the ratio of the Value added (constant 2005 US$) of Montenegro in 2006 to that in 2008?
Give a very brief answer. 0.87. What is the ratio of the Value added (constant 2005 US$) of Malaysia in 2007 to that in 2008?
Your response must be concise. 0.91. What is the ratio of the Value added (constant 2005 US$) of Montenegro in 2007 to that in 2008?
Your answer should be very brief. 1.01. What is the difference between the highest and the second highest Value added (constant 2005 US$) of Denmark?
Make the answer very short. 1.17e+09. What is the difference between the highest and the second highest Value added (constant 2005 US$) of Jamaica?
Your answer should be very brief. 2.92e+07. What is the difference between the highest and the second highest Value added (constant 2005 US$) in Malaysia?
Your response must be concise. 7.41e+09. What is the difference between the highest and the second highest Value added (constant 2005 US$) in Montenegro?
Give a very brief answer. 1.04e+07. What is the difference between the highest and the lowest Value added (constant 2005 US$) in Denmark?
Offer a terse response. 1.63e+1. What is the difference between the highest and the lowest Value added (constant 2005 US$) of Jamaica?
Offer a terse response. 5.92e+08. What is the difference between the highest and the lowest Value added (constant 2005 US$) of Malaysia?
Your response must be concise. 2.87e+1. What is the difference between the highest and the lowest Value added (constant 2005 US$) in Montenegro?
Keep it short and to the point. 2.70e+08. 